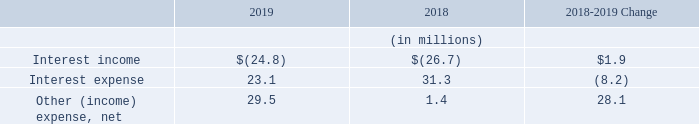Interest and Other
Interest income decreased by $1.9 million from 2018 to 2019 due primarily to lower cash and marketable securities balances in 2019. Interest expense decreased by $8.2 million from 2018 to 2019 due primarily to unrealized losses on equity marketable securities recognized in 2018. Other (income) expense, net increased by $28.1 million from 2018 to 2019 due primarily to a $15.0 million charge for the impairment of the investment in RealWear and an $11.5 million change in pension actuarial (gains) losses from a $3.3 million gain in 2018 to an $8.2 million loss in 2019.
What was the change in interest income in 2019? Decreased by $1.9 million. What was the change in interest expense in 2019? Decreased by $8.2 million. What are the components analyzed under Interest and Other in the table? Interest income, interest expense, other (income) expense, net. In which year was interest expense larger? 31.3>23.1
Answer: 2018. What was the percentage change in Interest expense in 2019 from 2018?
Answer scale should be: percent. (23.1-31.3)/31.3
Answer: -26.2. What was the percentage change in Other (income) expense, net in 2019 from 2018?
Answer scale should be: percent. (29.5-1.4)/1.4
Answer: 2007.14. 